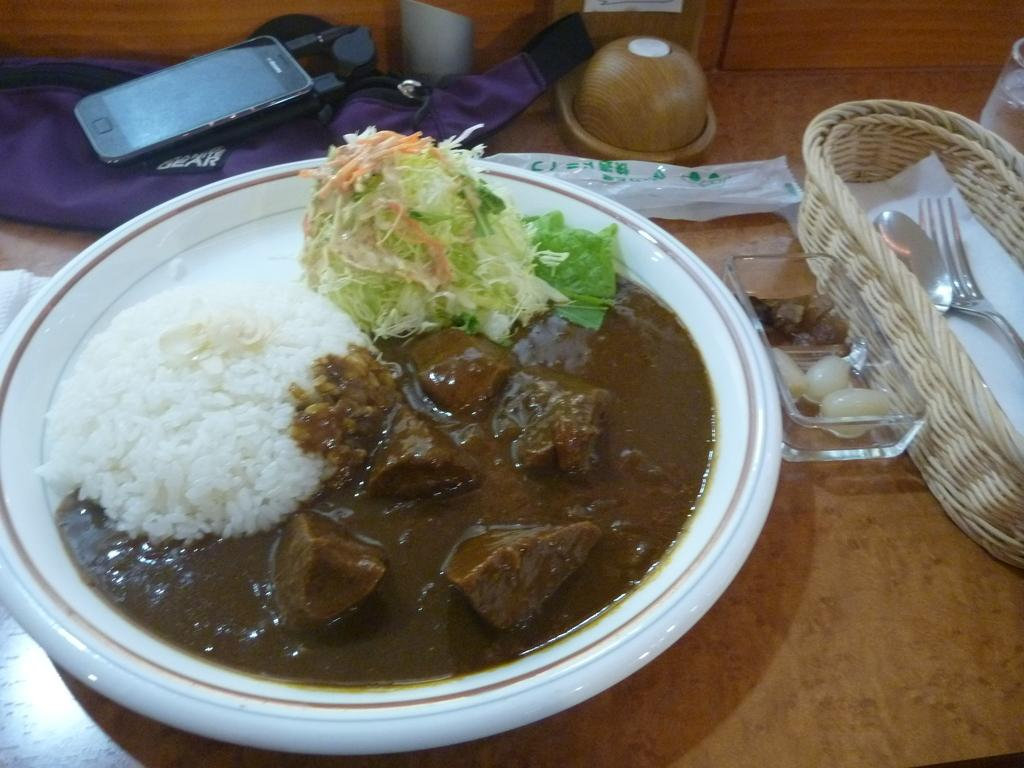What is on the plate in the image? There are food items on a plate in the image. What else can be seen on the table in the image? There are other objects on the table in the image. What is the opinion of the cushion in the image? There is no cushion present in the image, so it is not possible to determine its opinion. 